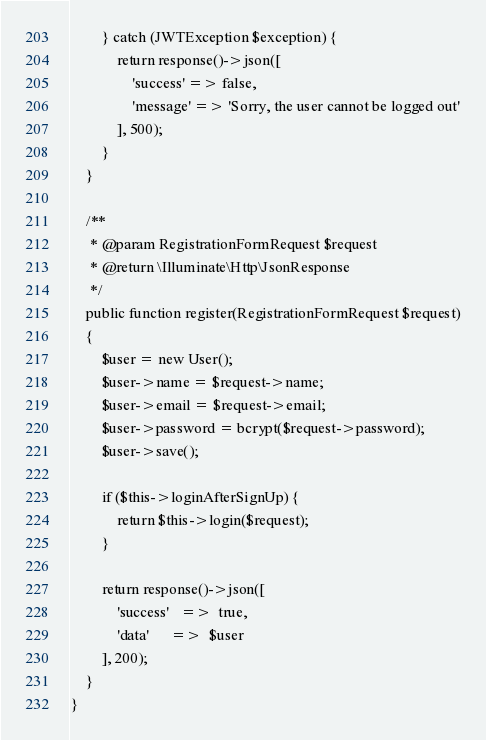<code> <loc_0><loc_0><loc_500><loc_500><_PHP_>        } catch (JWTException $exception) {
            return response()->json([
                'success' => false,
                'message' => 'Sorry, the user cannot be logged out'
            ], 500);
        }
    }

    /**
     * @param RegistrationFormRequest $request
     * @return \Illuminate\Http\JsonResponse
     */
    public function register(RegistrationFormRequest $request)
    {
        $user = new User();
        $user->name = $request->name;
        $user->email = $request->email;
        $user->password = bcrypt($request->password);
        $user->save();

        if ($this->loginAfterSignUp) {
            return $this->login($request);
        }

        return response()->json([
            'success'   =>  true,
            'data'      =>  $user
        ], 200);
    }
}</code> 